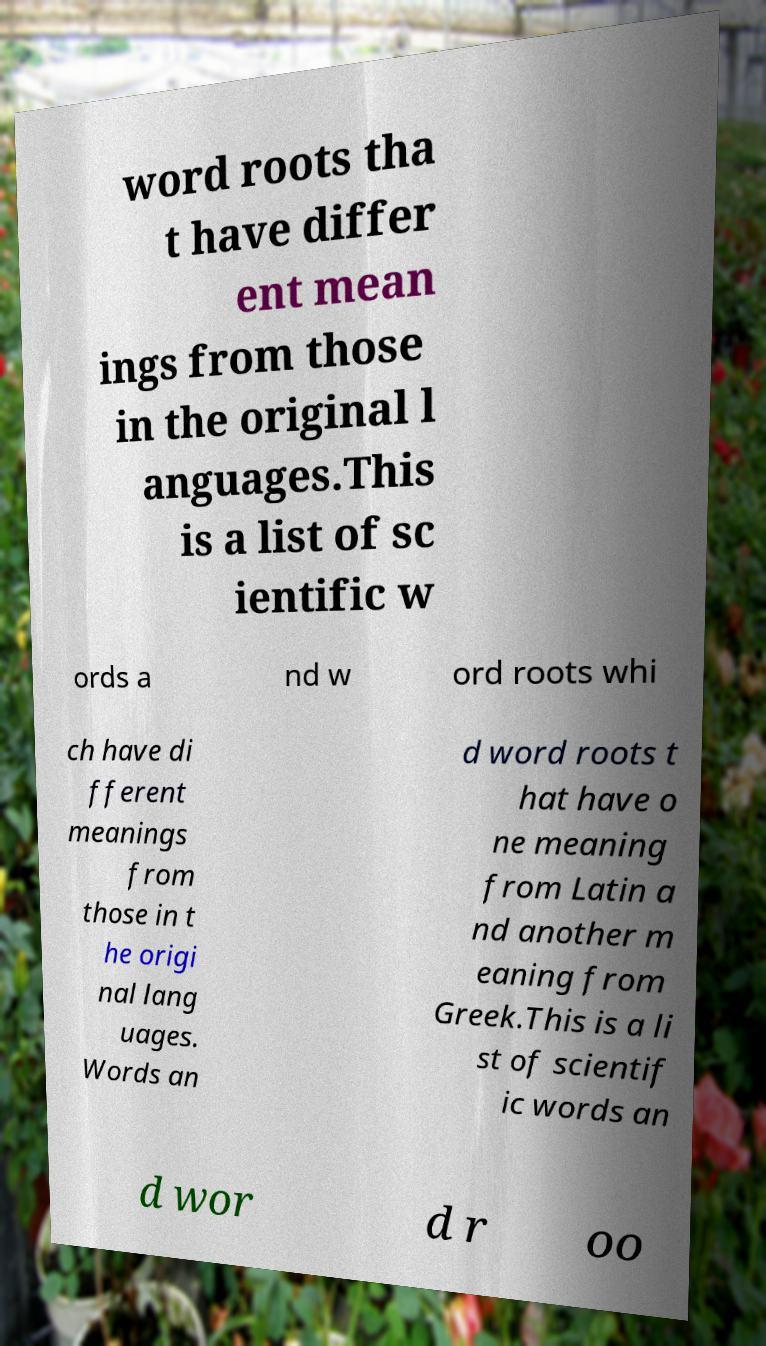I need the written content from this picture converted into text. Can you do that? word roots tha t have differ ent mean ings from those in the original l anguages.This is a list of sc ientific w ords a nd w ord roots whi ch have di fferent meanings from those in t he origi nal lang uages. Words an d word roots t hat have o ne meaning from Latin a nd another m eaning from Greek.This is a li st of scientif ic words an d wor d r oo 